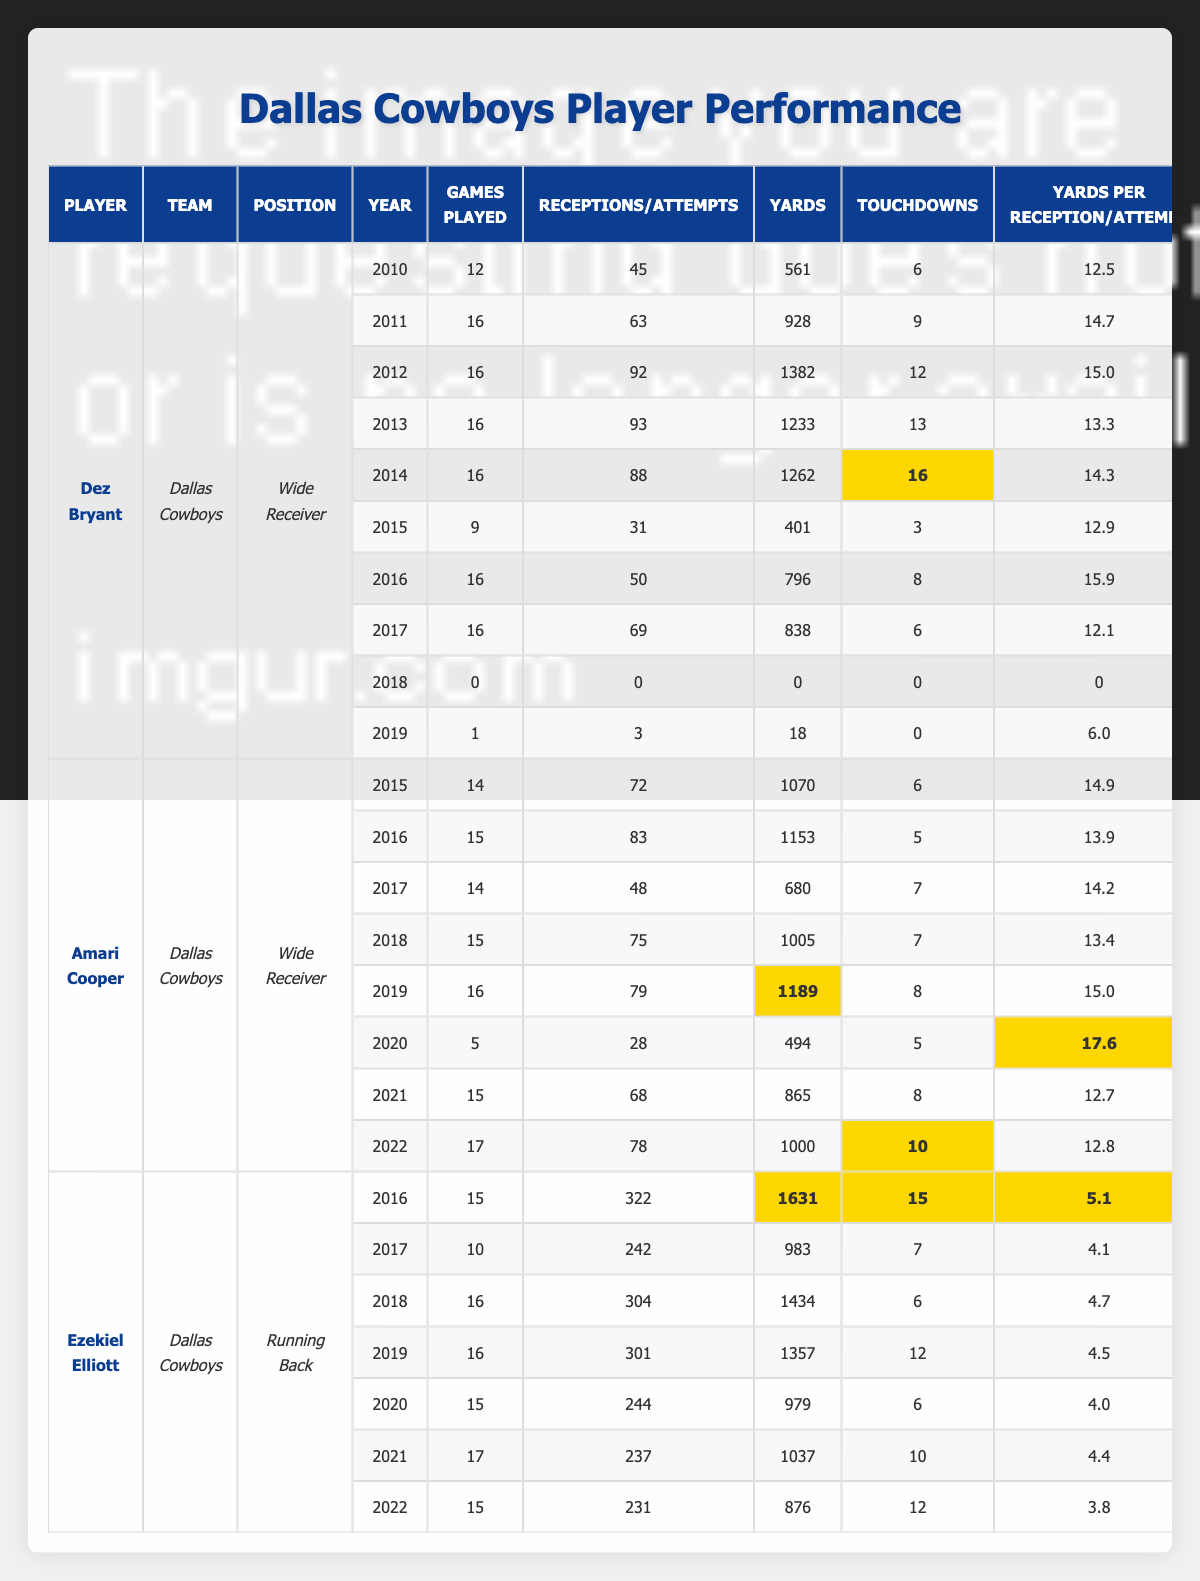What year did Dez Bryant have his highest number of touchdowns? In the table, look at the "Touchdowns" column for Dez Bryant. The highest value is 16, which he achieved in 2014.
Answer: 2014 How many total games did Amari Cooper play from 2015 to 2022? To find the total games played, we add up his games from each season: 14 + 15 + 14 + 15 + 16 + 5 + 15 + 17 = 111.
Answer: 111 Which player had the highest receiving yards in a single season? We compare the "Receiving Yards" for each player. Dez Bryant had the highest single-season yards at 1382 in 2012.
Answer: Dez Bryant (1382 yards in 2012) Did Ezekiel Elliott play more games in 2019 compared to 2017? Looking at the table, in 2019 Ezekiel played 16 games while in 2017 he played 10 games, therefore, he played more in 2019.
Answer: Yes What was the average touchdowns per season for Amari Cooper from 2015 to 2022? Calculate the total touchdowns: 6 + 5 + 7 + 7 + 8 + 5 + 8 + 10 = 56. Divide by the number of seasons (8): 56/8 = 7.
Answer: 7 How many more touchdowns did Ezekiel Elliott score in 2016 compared to 2022? In 2016, he had 15 touchdowns, while in 2022 he scored 12. The difference is 15 - 12 = 3.
Answer: 3 What was the highest yards per reception achieved by Dez Bryant? Looking at the "Yards Per Reception" column, his highest value is 15.0 in 2012.
Answer: 15.0 How many seasons did Amari Cooper have over 1000 receiving yards? From the table, he had over 1000 yards in 2015 (1070), 2016 (1153), 2018 (1005), and 2019 (1189). That totals to 4 seasons.
Answer: 4 Which player had the most games played in a single season? Check the "Games Played" column; both Amari Cooper and Ezekiel Elliott had 17 games played in 2021.
Answer: Amari Cooper and Ezekiel Elliott (17 games in 2021) During which year did Dez Bryant not play any games? Looking at the "Year" and "Games Played" columns together, 2018 shows 0 games played for Dez Bryant.
Answer: 2018 What was the total number of rushing attempts for Ezekiel Elliott in 2019? In the table, under the 2019 row for Ezekiel Elliott, he had 301 rushing attempts.
Answer: 301 